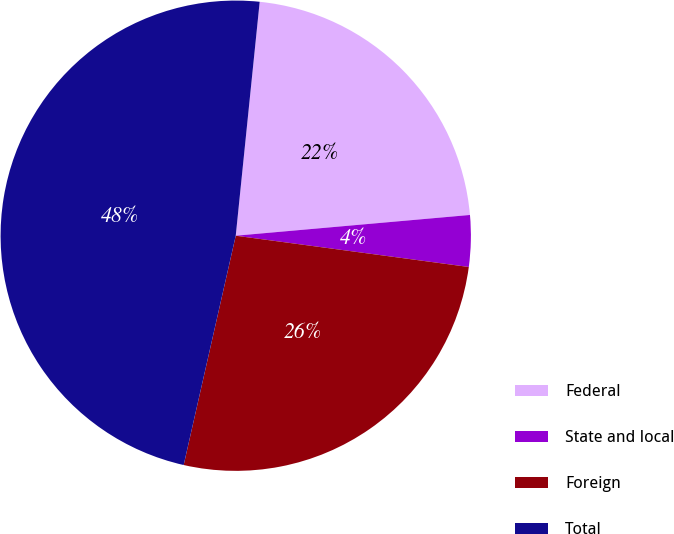Convert chart. <chart><loc_0><loc_0><loc_500><loc_500><pie_chart><fcel>Federal<fcel>State and local<fcel>Foreign<fcel>Total<nl><fcel>21.97%<fcel>3.53%<fcel>26.43%<fcel>48.07%<nl></chart> 